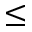<formula> <loc_0><loc_0><loc_500><loc_500>\leq</formula> 